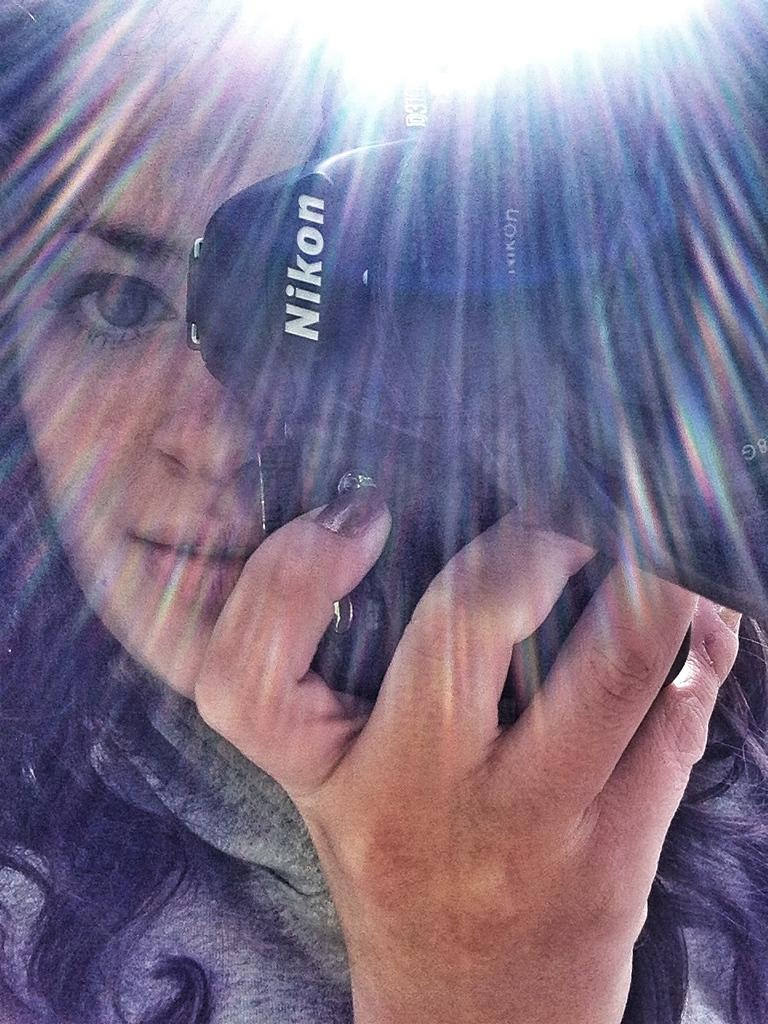<image>
Write a terse but informative summary of the picture. the woman is using a Nikon camera to take the picture 